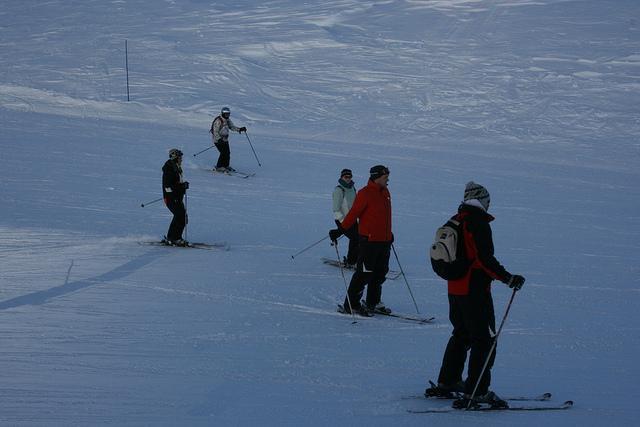How many people are in the photo?
Give a very brief answer. 5. How many snow skis do you see?
Give a very brief answer. 10. How many people are there?
Give a very brief answer. 2. How many bowls are uncovered?
Give a very brief answer. 0. 